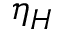<formula> <loc_0><loc_0><loc_500><loc_500>\eta _ { H }</formula> 